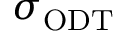Convert formula to latex. <formula><loc_0><loc_0><loc_500><loc_500>\sigma _ { O D T }</formula> 